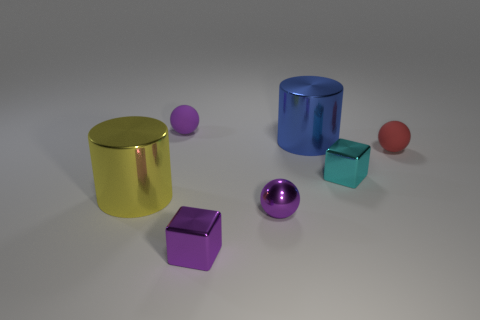How many metal objects are tiny cyan things or blocks?
Ensure brevity in your answer.  2. What is the material of the red ball that is the same size as the cyan thing?
Your answer should be very brief. Rubber. Are there any other tiny objects made of the same material as the red object?
Offer a terse response. Yes. What shape is the small metallic thing that is in front of the ball that is in front of the tiny matte thing right of the purple metallic ball?
Provide a short and direct response. Cube. There is a cyan metal cube; is it the same size as the rubber object that is to the right of the tiny cyan shiny thing?
Ensure brevity in your answer.  Yes. The purple thing that is both behind the purple shiny cube and in front of the yellow shiny object has what shape?
Offer a very short reply. Sphere. How many tiny objects are blocks or rubber things?
Your answer should be compact. 4. Is the number of blue metal objects that are in front of the large yellow cylinder the same as the number of small spheres behind the small purple matte ball?
Offer a very short reply. Yes. What number of other objects are the same color as the tiny metal ball?
Your answer should be very brief. 2. Are there the same number of large things that are to the right of the small cyan metal block and tiny yellow shiny objects?
Make the answer very short. Yes. 